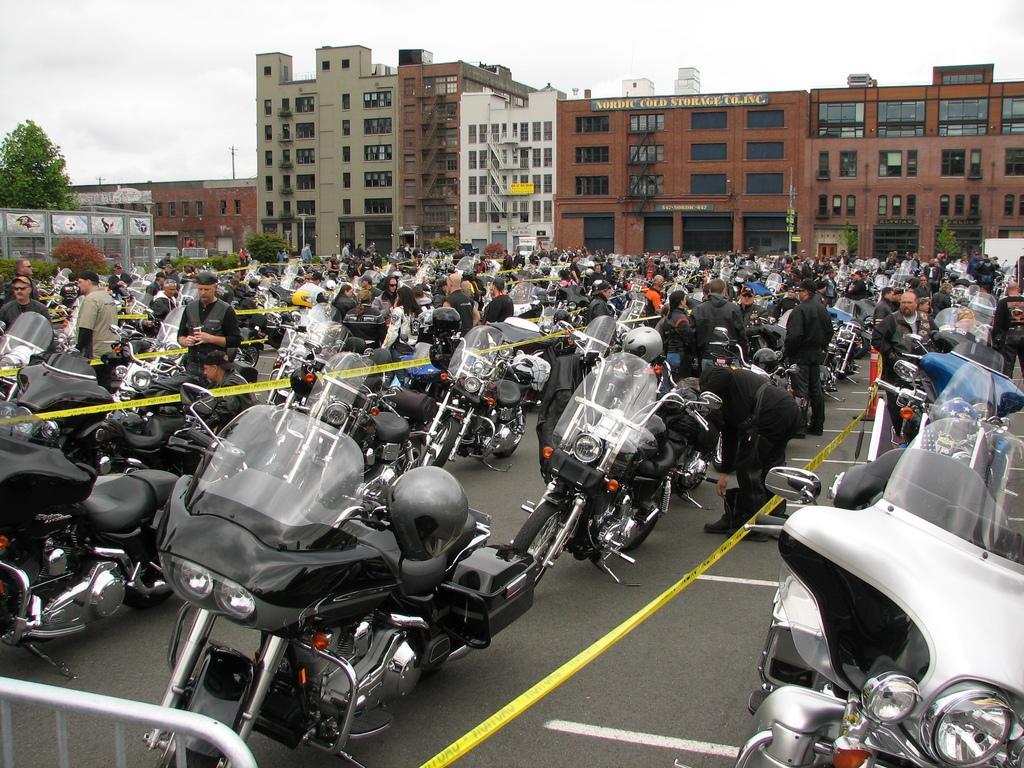Describe this image in one or two sentences. In this picture we can see motor bikes and a group of people standing on the road, helmets, caution tapes, buildings with windows, trees, banners and some objects and in the background we can see the sky with clouds. 